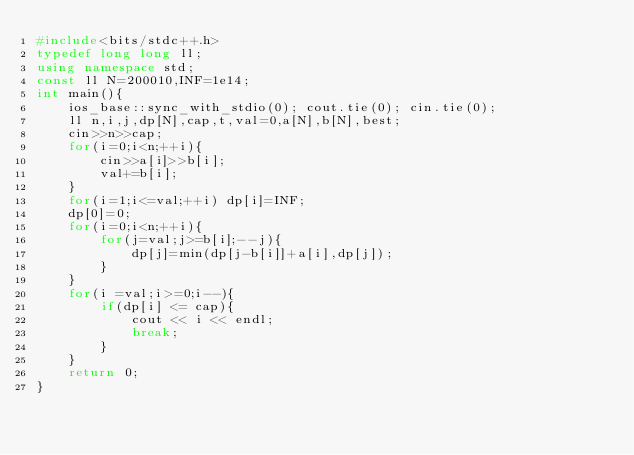<code> <loc_0><loc_0><loc_500><loc_500><_C++_>#include<bits/stdc++.h>
typedef long long ll;
using namespace std;
const ll N=200010,INF=1e14;
int main(){
	ios_base::sync_with_stdio(0); cout.tie(0); cin.tie(0);
	ll n,i,j,dp[N],cap,t,val=0,a[N],b[N],best;
	cin>>n>>cap;
	for(i=0;i<n;++i){
		cin>>a[i]>>b[i];
		val+=b[i];
	}
	for(i=1;i<=val;++i) dp[i]=INF;
	dp[0]=0;
	for(i=0;i<n;++i){
		for(j=val;j>=b[i];--j){
			dp[j]=min(dp[j-b[i]]+a[i],dp[j]);
		}
	}
	for(i =val;i>=0;i--){
		if(dp[i] <= cap){
			cout << i << endl;
			break;
		}
	}
	return 0;
}</code> 